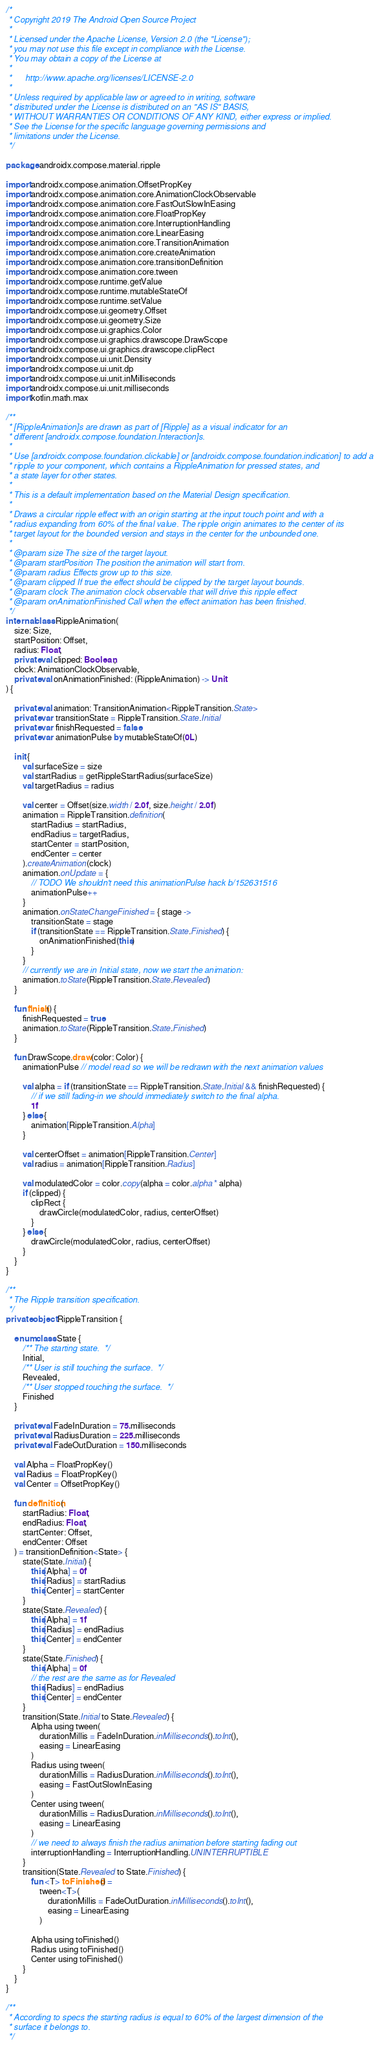<code> <loc_0><loc_0><loc_500><loc_500><_Kotlin_>/*
 * Copyright 2019 The Android Open Source Project
 *
 * Licensed under the Apache License, Version 2.0 (the "License");
 * you may not use this file except in compliance with the License.
 * You may obtain a copy of the License at
 *
 *      http://www.apache.org/licenses/LICENSE-2.0
 *
 * Unless required by applicable law or agreed to in writing, software
 * distributed under the License is distributed on an "AS IS" BASIS,
 * WITHOUT WARRANTIES OR CONDITIONS OF ANY KIND, either express or implied.
 * See the License for the specific language governing permissions and
 * limitations under the License.
 */

package androidx.compose.material.ripple

import androidx.compose.animation.OffsetPropKey
import androidx.compose.animation.core.AnimationClockObservable
import androidx.compose.animation.core.FastOutSlowInEasing
import androidx.compose.animation.core.FloatPropKey
import androidx.compose.animation.core.InterruptionHandling
import androidx.compose.animation.core.LinearEasing
import androidx.compose.animation.core.TransitionAnimation
import androidx.compose.animation.core.createAnimation
import androidx.compose.animation.core.transitionDefinition
import androidx.compose.animation.core.tween
import androidx.compose.runtime.getValue
import androidx.compose.runtime.mutableStateOf
import androidx.compose.runtime.setValue
import androidx.compose.ui.geometry.Offset
import androidx.compose.ui.geometry.Size
import androidx.compose.ui.graphics.Color
import androidx.compose.ui.graphics.drawscope.DrawScope
import androidx.compose.ui.graphics.drawscope.clipRect
import androidx.compose.ui.unit.Density
import androidx.compose.ui.unit.dp
import androidx.compose.ui.unit.inMilliseconds
import androidx.compose.ui.unit.milliseconds
import kotlin.math.max

/**
 * [RippleAnimation]s are drawn as part of [Ripple] as a visual indicator for an
 * different [androidx.compose.foundation.Interaction]s.
 *
 * Use [androidx.compose.foundation.clickable] or [androidx.compose.foundation.indication] to add a
 * ripple to your component, which contains a RippleAnimation for pressed states, and
 * a state layer for other states.
 *
 * This is a default implementation based on the Material Design specification.
 *
 * Draws a circular ripple effect with an origin starting at the input touch point and with a
 * radius expanding from 60% of the final value. The ripple origin animates to the center of its
 * target layout for the bounded version and stays in the center for the unbounded one.
 *
 * @param size The size of the target layout.
 * @param startPosition The position the animation will start from.
 * @param radius Effects grow up to this size.
 * @param clipped If true the effect should be clipped by the target layout bounds.
 * @param clock The animation clock observable that will drive this ripple effect
 * @param onAnimationFinished Call when the effect animation has been finished.
 */
internal class RippleAnimation(
    size: Size,
    startPosition: Offset,
    radius: Float,
    private val clipped: Boolean,
    clock: AnimationClockObservable,
    private val onAnimationFinished: (RippleAnimation) -> Unit
) {

    private val animation: TransitionAnimation<RippleTransition.State>
    private var transitionState = RippleTransition.State.Initial
    private var finishRequested = false
    private var animationPulse by mutableStateOf(0L)

    init {
        val surfaceSize = size
        val startRadius = getRippleStartRadius(surfaceSize)
        val targetRadius = radius

        val center = Offset(size.width / 2.0f, size.height / 2.0f)
        animation = RippleTransition.definition(
            startRadius = startRadius,
            endRadius = targetRadius,
            startCenter = startPosition,
            endCenter = center
        ).createAnimation(clock)
        animation.onUpdate = {
            // TODO We shouldn't need this animationPulse hack b/152631516
            animationPulse++
        }
        animation.onStateChangeFinished = { stage ->
            transitionState = stage
            if (transitionState == RippleTransition.State.Finished) {
                onAnimationFinished(this)
            }
        }
        // currently we are in Initial state, now we start the animation:
        animation.toState(RippleTransition.State.Revealed)
    }

    fun finish() {
        finishRequested = true
        animation.toState(RippleTransition.State.Finished)
    }

    fun DrawScope.draw(color: Color) {
        animationPulse // model read so we will be redrawn with the next animation values

        val alpha = if (transitionState == RippleTransition.State.Initial && finishRequested) {
            // if we still fading-in we should immediately switch to the final alpha.
            1f
        } else {
            animation[RippleTransition.Alpha]
        }

        val centerOffset = animation[RippleTransition.Center]
        val radius = animation[RippleTransition.Radius]

        val modulatedColor = color.copy(alpha = color.alpha * alpha)
        if (clipped) {
            clipRect {
                drawCircle(modulatedColor, radius, centerOffset)
            }
        } else {
            drawCircle(modulatedColor, radius, centerOffset)
        }
    }
}

/**
 * The Ripple transition specification.
 */
private object RippleTransition {

    enum class State {
        /** The starting state.  */
        Initial,
        /** User is still touching the surface.  */
        Revealed,
        /** User stopped touching the surface.  */
        Finished
    }

    private val FadeInDuration = 75.milliseconds
    private val RadiusDuration = 225.milliseconds
    private val FadeOutDuration = 150.milliseconds

    val Alpha = FloatPropKey()
    val Radius = FloatPropKey()
    val Center = OffsetPropKey()

    fun definition(
        startRadius: Float,
        endRadius: Float,
        startCenter: Offset,
        endCenter: Offset
    ) = transitionDefinition<State> {
        state(State.Initial) {
            this[Alpha] = 0f
            this[Radius] = startRadius
            this[Center] = startCenter
        }
        state(State.Revealed) {
            this[Alpha] = 1f
            this[Radius] = endRadius
            this[Center] = endCenter
        }
        state(State.Finished) {
            this[Alpha] = 0f
            // the rest are the same as for Revealed
            this[Radius] = endRadius
            this[Center] = endCenter
        }
        transition(State.Initial to State.Revealed) {
            Alpha using tween(
                durationMillis = FadeInDuration.inMilliseconds().toInt(),
                easing = LinearEasing
            )
            Radius using tween(
                durationMillis = RadiusDuration.inMilliseconds().toInt(),
                easing = FastOutSlowInEasing
            )
            Center using tween(
                durationMillis = RadiusDuration.inMilliseconds().toInt(),
                easing = LinearEasing
            )
            // we need to always finish the radius animation before starting fading out
            interruptionHandling = InterruptionHandling.UNINTERRUPTIBLE
        }
        transition(State.Revealed to State.Finished) {
            fun <T> toFinished() =
                tween<T>(
                    durationMillis = FadeOutDuration.inMilliseconds().toInt(),
                    easing = LinearEasing
                )

            Alpha using toFinished()
            Radius using toFinished()
            Center using toFinished()
        }
    }
}

/**
 * According to specs the starting radius is equal to 60% of the largest dimension of the
 * surface it belongs to.
 */</code> 